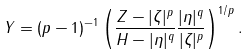Convert formula to latex. <formula><loc_0><loc_0><loc_500><loc_500>Y = ( p - 1 ) ^ { - 1 } \left ( \frac { Z - | \zeta | ^ { p } } { H - | \eta | ^ { q } } \frac { | \eta | ^ { q } } { | \zeta | ^ { p } } \right ) ^ { 1 / p } .</formula> 